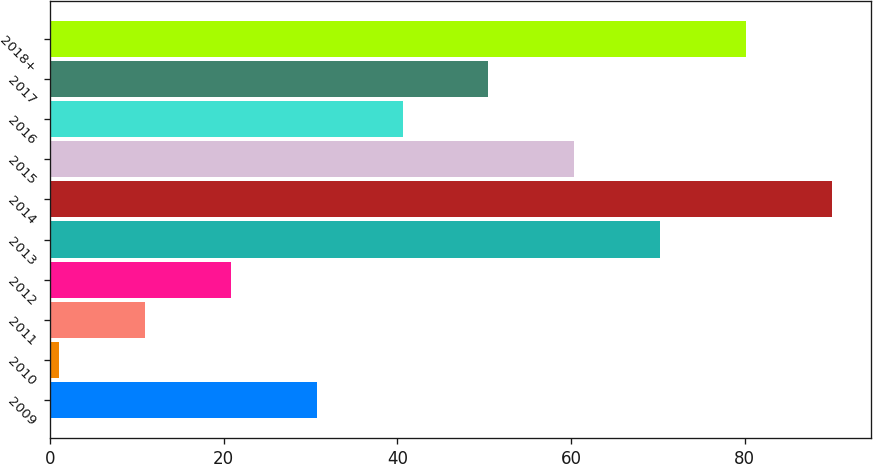<chart> <loc_0><loc_0><loc_500><loc_500><bar_chart><fcel>2009<fcel>2010<fcel>2011<fcel>2012<fcel>2013<fcel>2014<fcel>2015<fcel>2016<fcel>2017<fcel>2018+<nl><fcel>30.7<fcel>1<fcel>10.9<fcel>20.8<fcel>70.3<fcel>90.1<fcel>60.4<fcel>40.6<fcel>50.5<fcel>80.2<nl></chart> 